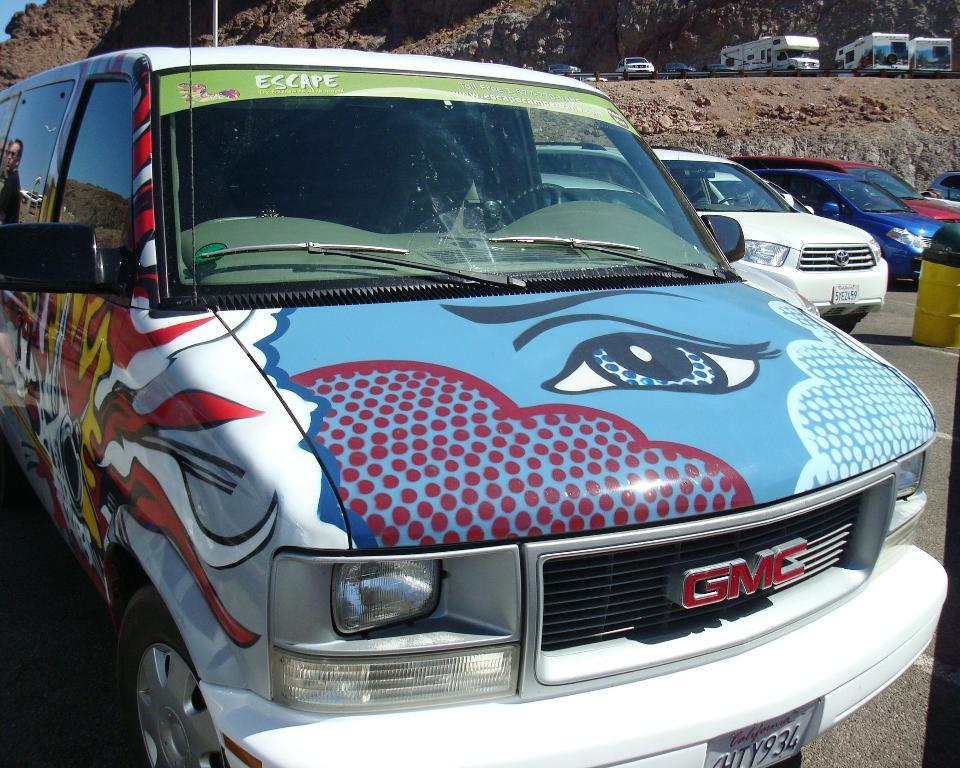<image>
Relay a brief, clear account of the picture shown. White van which says GMC in red letters on the front. 